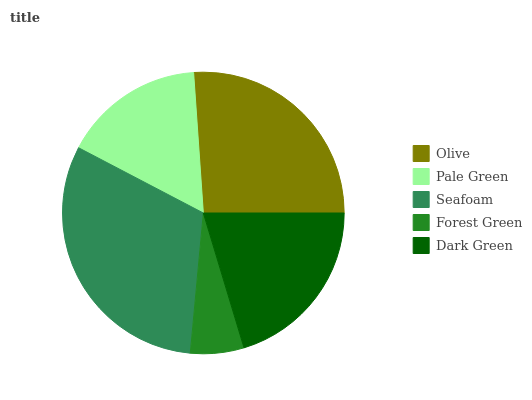Is Forest Green the minimum?
Answer yes or no. Yes. Is Seafoam the maximum?
Answer yes or no. Yes. Is Pale Green the minimum?
Answer yes or no. No. Is Pale Green the maximum?
Answer yes or no. No. Is Olive greater than Pale Green?
Answer yes or no. Yes. Is Pale Green less than Olive?
Answer yes or no. Yes. Is Pale Green greater than Olive?
Answer yes or no. No. Is Olive less than Pale Green?
Answer yes or no. No. Is Dark Green the high median?
Answer yes or no. Yes. Is Dark Green the low median?
Answer yes or no. Yes. Is Seafoam the high median?
Answer yes or no. No. Is Pale Green the low median?
Answer yes or no. No. 